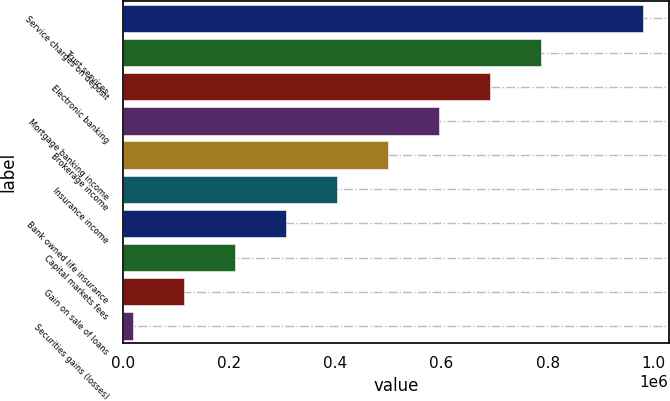<chart> <loc_0><loc_0><loc_500><loc_500><bar_chart><fcel>Service charges on deposit<fcel>Trust services<fcel>Electronic banking<fcel>Mortgage banking income<fcel>Brokerage income<fcel>Insurance income<fcel>Bank owned life insurance<fcel>Capital markets fees<fcel>Gain on sale of loans<fcel>Securities gains (losses)<nl><fcel>979179<fcel>786854<fcel>690692<fcel>594529<fcel>498366<fcel>402204<fcel>306042<fcel>209879<fcel>113716<fcel>17554<nl></chart> 